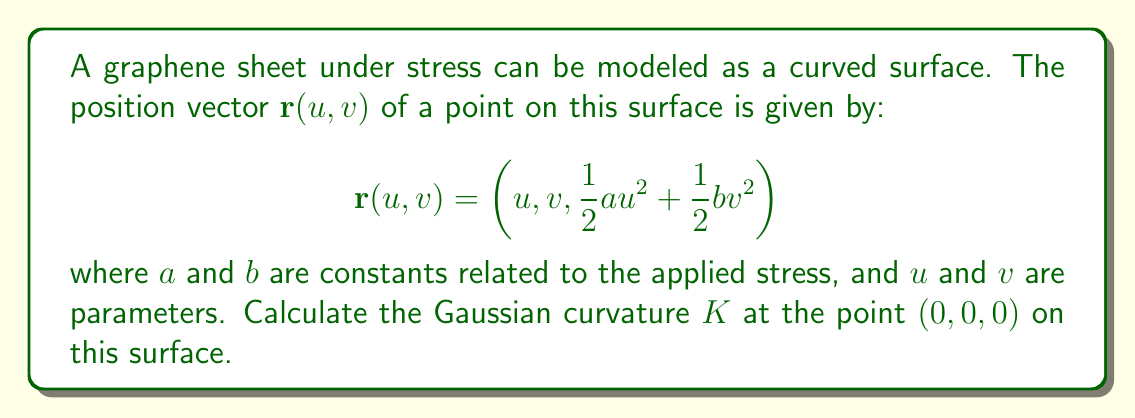What is the answer to this math problem? To calculate the Gaussian curvature, we need to follow these steps:

1) First, we need to calculate the partial derivatives of $\mathbf{r}$ with respect to $u$ and $v$:

   $$\mathbf{r}_u = (1, 0, au)$$
   $$\mathbf{r}_v = (0, 1, bv)$$

2) Next, we calculate the second partial derivatives:

   $$\mathbf{r}_{uu} = (0, 0, a)$$
   $$\mathbf{r}_{uv} = \mathbf{r}_{vu} = (0, 0, 0)$$
   $$\mathbf{r}_{vv} = (0, 0, b)$$

3) Now we need to calculate the coefficients of the first fundamental form:

   $$E = \mathbf{r}_u \cdot \mathbf{r}_u = 1 + a^2u^2$$
   $$F = \mathbf{r}_u \cdot \mathbf{r}_v = abu v$$
   $$G = \mathbf{r}_v \cdot \mathbf{r}_v = 1 + b^2v^2$$

4) And the coefficients of the second fundamental form:

   $$e = \frac{\mathbf{r}_{uu} \cdot (\mathbf{r}_u \times \mathbf{r}_v)}{\|\mathbf{r}_u \times \mathbf{r}_v\|} = \frac{a}{\sqrt{1 + a^2u^2 + b^2v^2}}$$
   $$f = \frac{\mathbf{r}_{uv} \cdot (\mathbf{r}_u \times \mathbf{r}_v)}{\|\mathbf{r}_u \times \mathbf{r}_v\|} = 0$$
   $$g = \frac{\mathbf{r}_{vv} \cdot (\mathbf{r}_u \times \mathbf{r}_v)}{\|\mathbf{r}_u \times \mathbf{r}_v\|} = \frac{b}{\sqrt{1 + a^2u^2 + b^2v^2}}$$

5) The Gaussian curvature is given by:

   $$K = \frac{eg - f^2}{EG - F^2}$$

6) At the point $(0,0,0)$, we have:

   $$E = G = 1, F = 0$$
   $$e = a, f = 0, g = b$$

7) Substituting these values into the formula for $K$:

   $$K = \frac{ab - 0^2}{1 \cdot 1 - 0^2} = ab$$

Therefore, the Gaussian curvature at $(0,0,0)$ is $ab$.
Answer: The Gaussian curvature $K$ at the point $(0,0,0)$ on the graphene sheet is $ab$. 